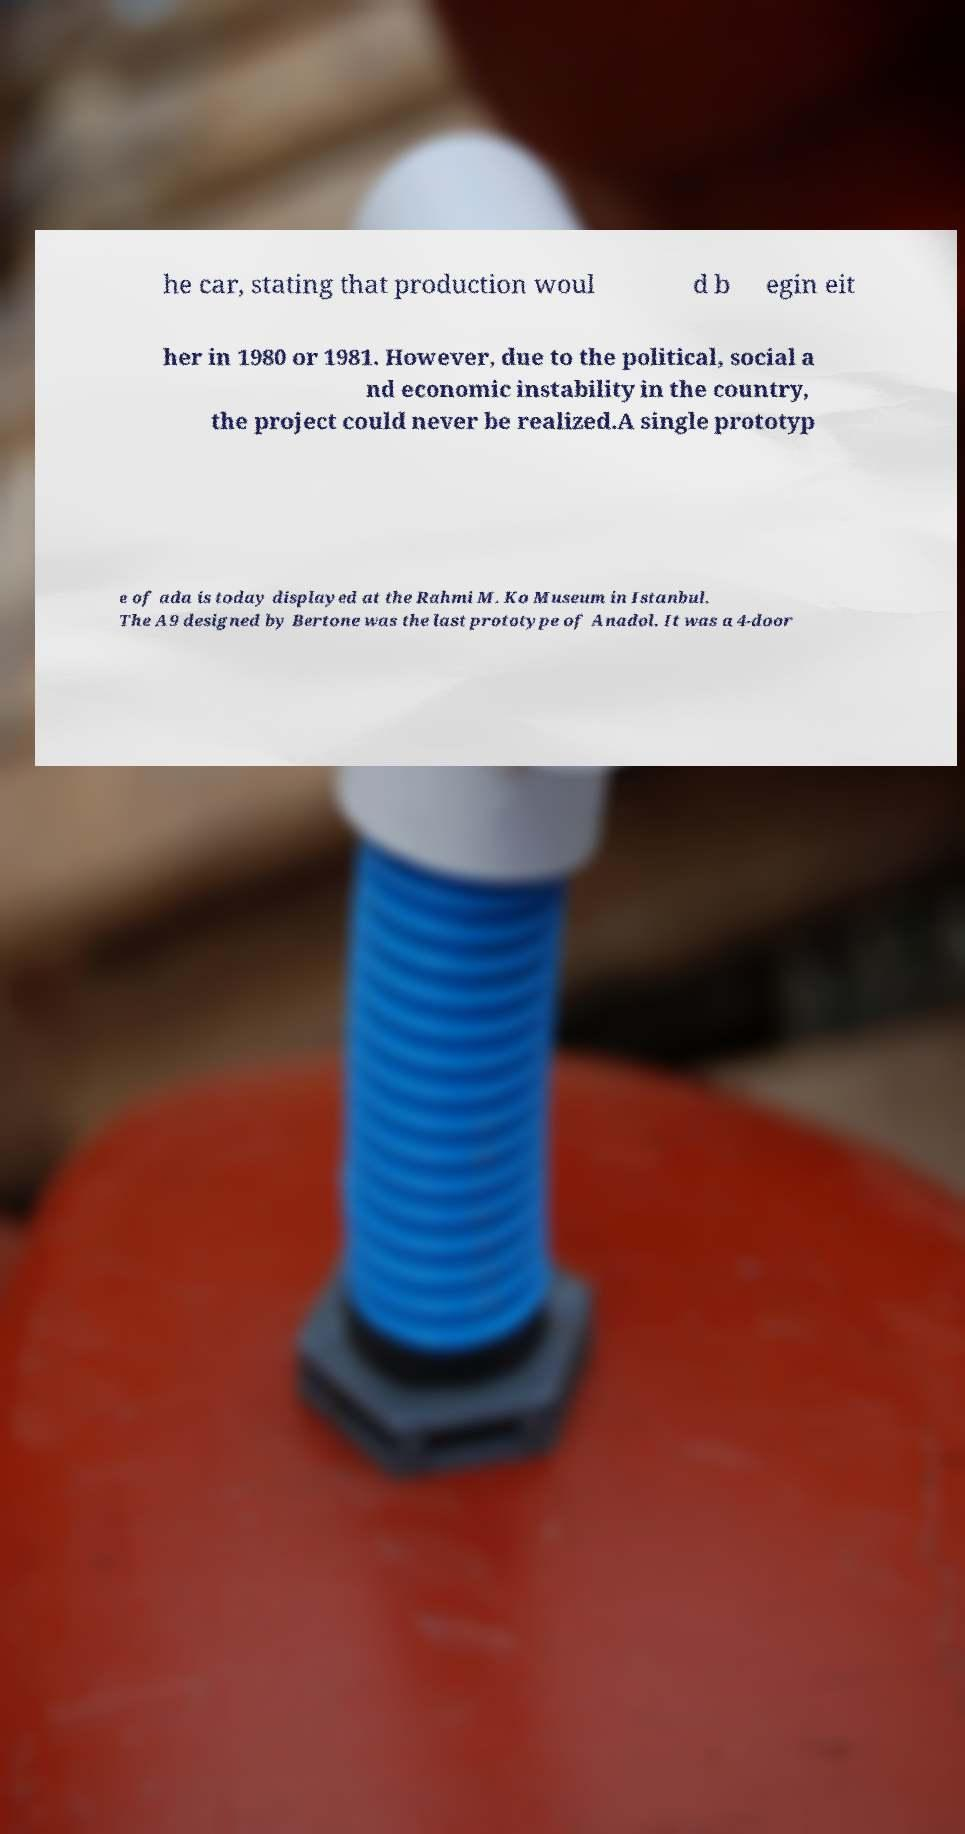Could you assist in decoding the text presented in this image and type it out clearly? he car, stating that production woul d b egin eit her in 1980 or 1981. However, due to the political, social a nd economic instability in the country, the project could never be realized.A single prototyp e of ada is today displayed at the Rahmi M. Ko Museum in Istanbul. The A9 designed by Bertone was the last prototype of Anadol. It was a 4-door 